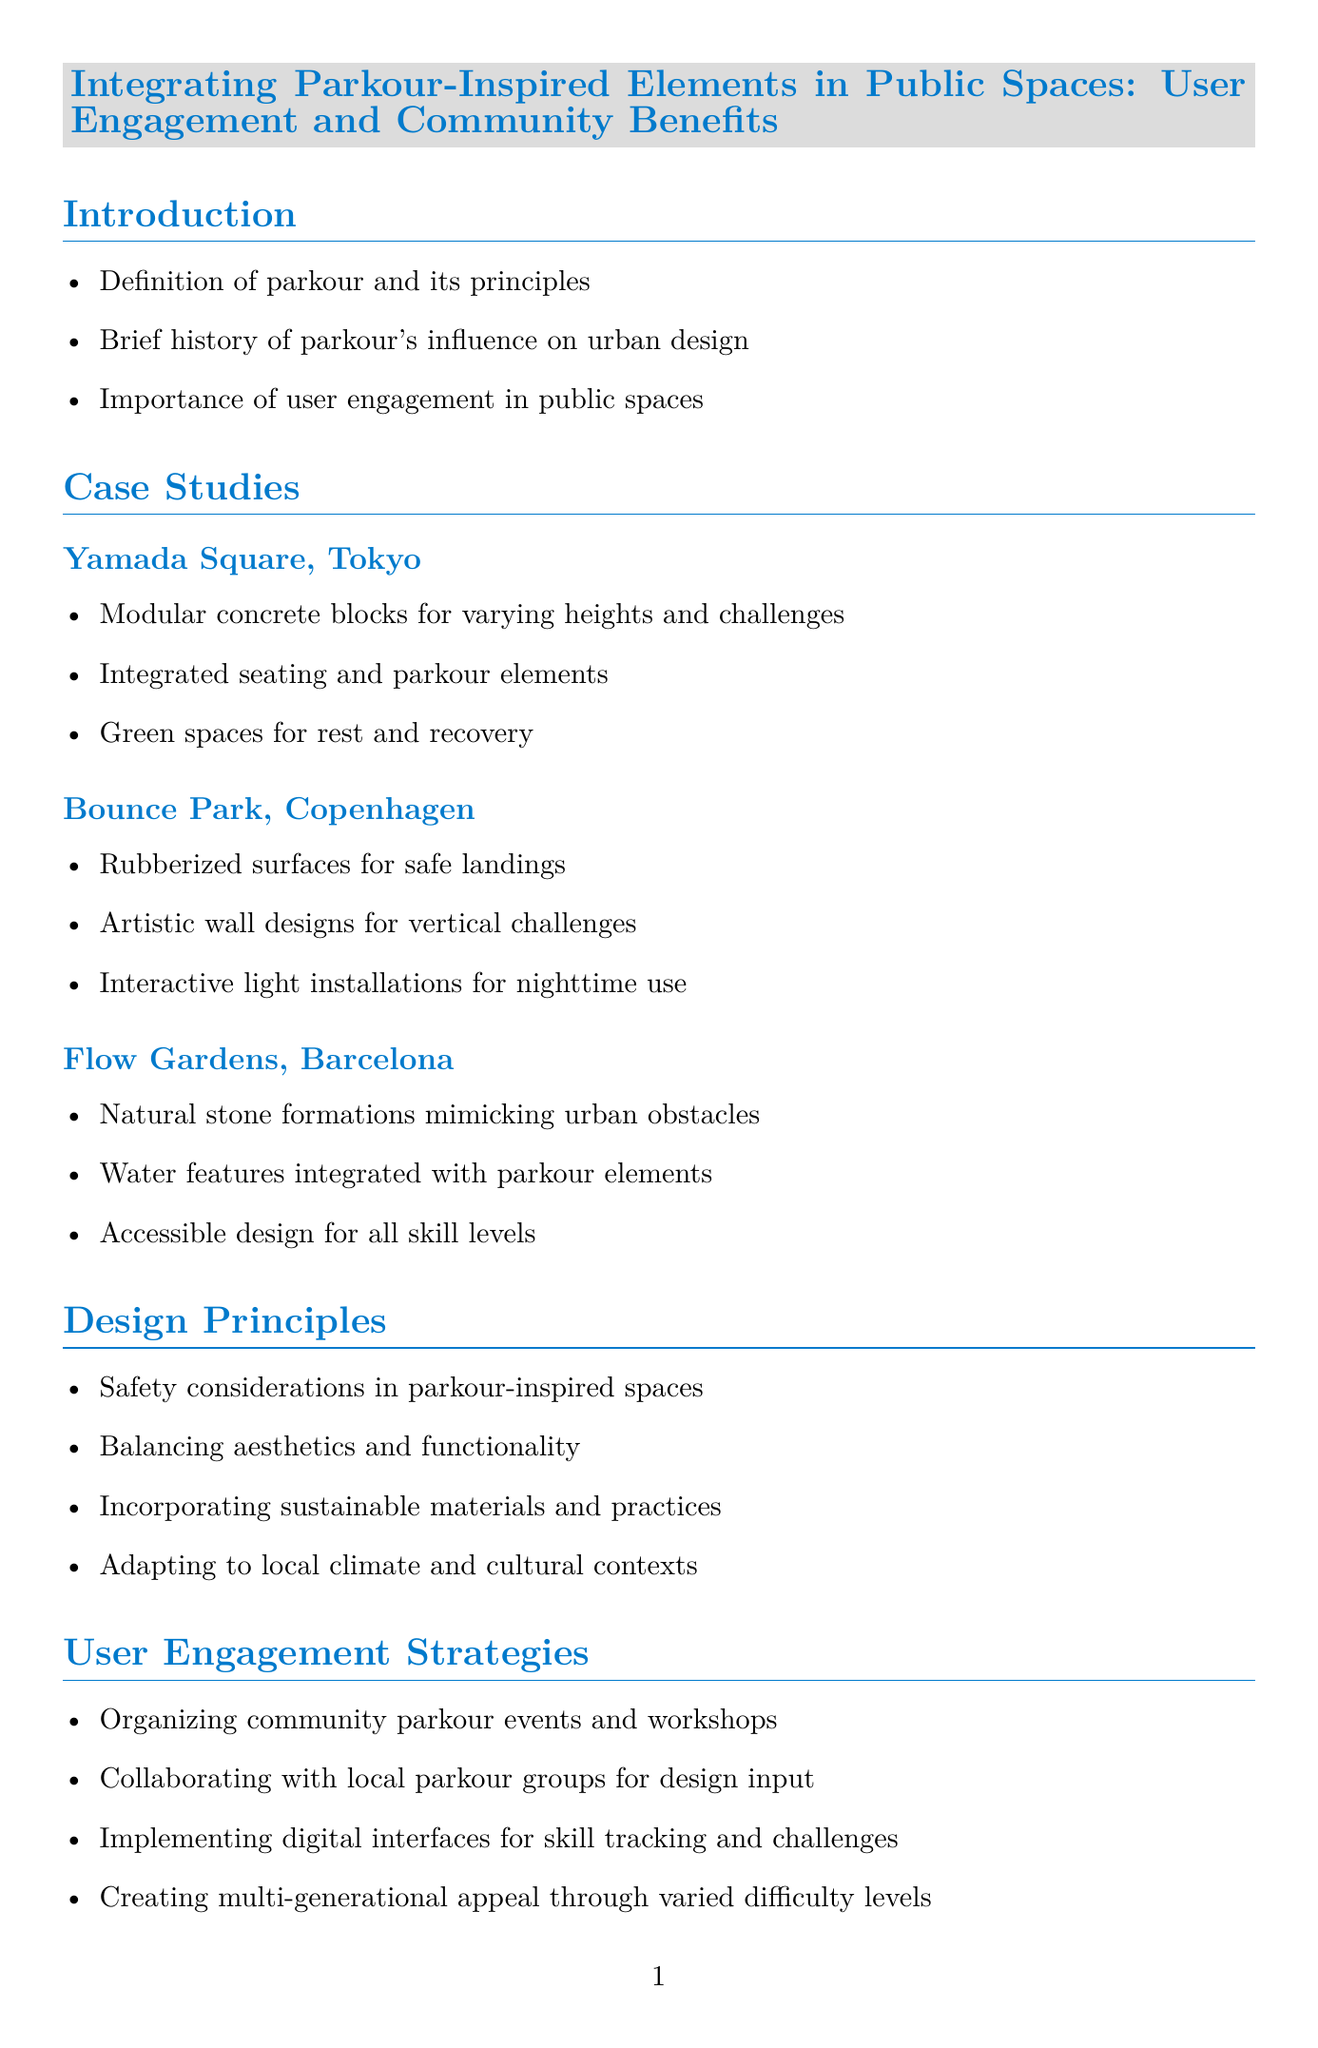What are the principles of parkour? The document lists the principles of parkour in the introduction section, which include its foundational concepts.
Answer: Principles of parkour What is the name of the parkour space in Tokyo? The case study section mentions Yamada Square as the location of a parkour-inspired public space in Tokyo.
Answer: Yamada Square What are the main features of Bounce Park? The case studies section provides features of Bounce Park, which include details specifically related to this location.
Answer: Rubberized surfaces for safe landings What are some community benefits mentioned in the report? The document discusses multiple community benefits in the community benefits section, outlining the positive impacts of these spaces.
Answer: Economic benefits through increased foot traffic and tourism What kind of visual data is presented in this report? The report includes several visual elements, which provide relevant demographic or activity insights in the context of parkour spaces.
Answer: Infographic, Heat Map, Before and After Comparison What is one user engagement strategy mentioned? The user engagement strategies section indicates several approaches to enhance community involvement with parkour spaces.
Answer: Organizing community parkour events and workshops How can user interaction influence design? The future trends section highlights the importance of user interaction in shaping parkour space designs, illustrating evolving design principles.
Answer: Adaptive designs that change based on user interaction and weather conditions Who is the founder of Freerunning mentioned in the expert insights? The expert insights section provides specific names and contributions from notable figures in the parkour community.
Answer: Sébastien Foucan What is a challenge faced by parkour spaces? The challenges and solutions section identifies common issues related to parkour-inspired public spaces, along with potential solutions.
Answer: Addressing liability concerns through proper signage and waivers 